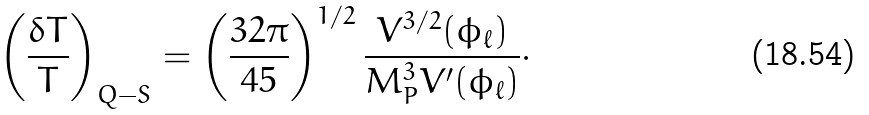Convert formula to latex. <formula><loc_0><loc_0><loc_500><loc_500>\left ( \frac { \delta T } { T } \right ) _ { Q - S } = \left ( \frac { 3 2 \pi } { 4 5 } \right ) ^ { 1 / 2 } \frac { V ^ { 3 / 2 } ( \phi _ { \ell } ) } { M ^ { 3 } _ { P } V ^ { \prime } ( \phi _ { \ell } ) } \cdot</formula> 